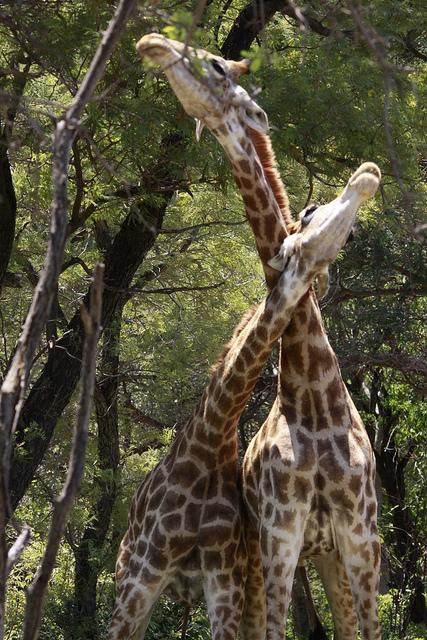Can't the animal reach the leaves behind it?
Quick response, please. Yes. What is the animal doing?
Concise answer only. Eating. What is hanging down in front of the giraffe?
Answer briefly. Branch. Are these two giraffes loving each other?
Be succinct. Yes. Are there any trees in the background of this photo?
Short answer required. Yes. Is this animal happy?
Keep it brief. Yes. Is the giraffe in its natural habitat or captivity?
Short answer required. Natural habitat. Is the giraffe looking at the camera?
Quick response, please. No. Does the giraffe look sad?
Write a very short answer. No. Are the giraffes eating?
Concise answer only. Yes. Are the animals in a man-made area?
Keep it brief. No. Where are the animals at?
Short answer required. Forest. 